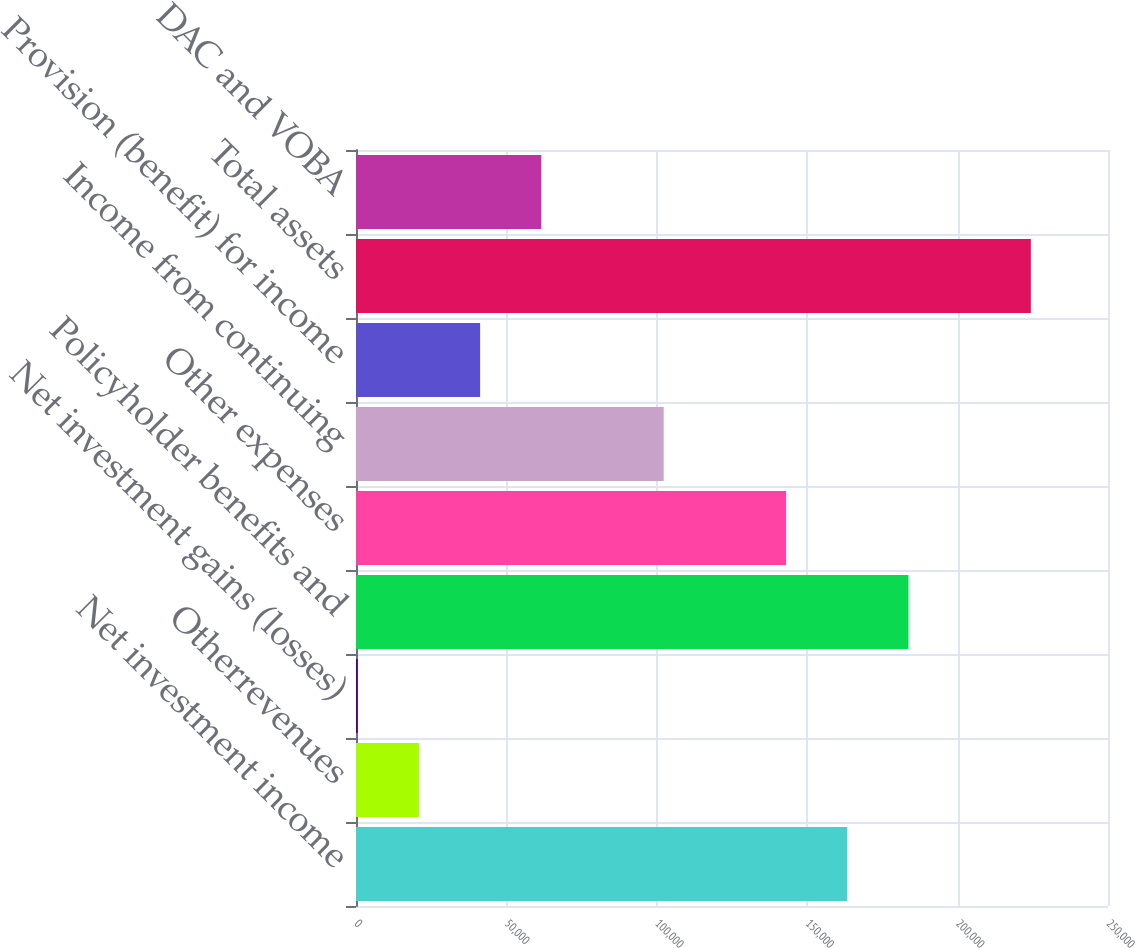Convert chart. <chart><loc_0><loc_0><loc_500><loc_500><bar_chart><fcel>Net investment income<fcel>Otherrevenues<fcel>Net investment gains (losses)<fcel>Policyholder benefits and<fcel>Other expenses<fcel>Income from continuing<fcel>Provision (benefit) for income<fcel>Total assets<fcel>DAC and VOBA<nl><fcel>163320<fcel>20922.5<fcel>580<fcel>183662<fcel>142978<fcel>102292<fcel>41265<fcel>224348<fcel>61607.5<nl></chart> 